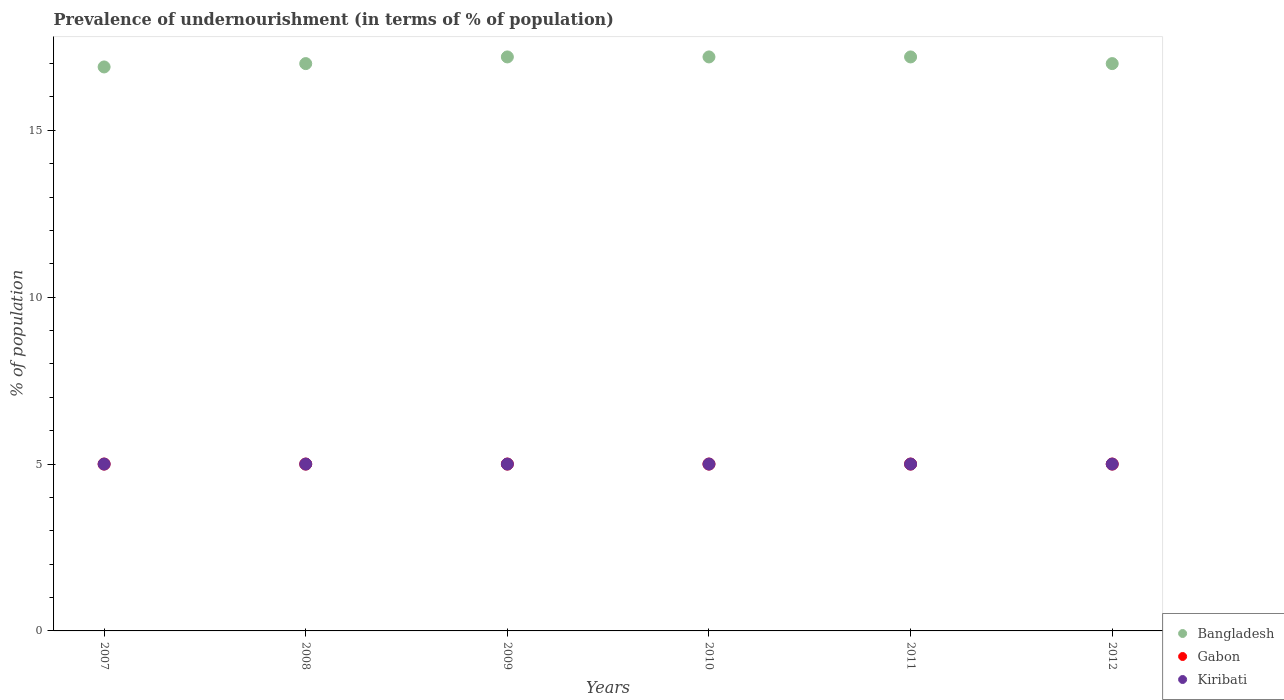How many different coloured dotlines are there?
Give a very brief answer. 3. What is the percentage of undernourished population in Gabon in 2009?
Provide a short and direct response. 5. Across all years, what is the maximum percentage of undernourished population in Gabon?
Offer a very short reply. 5. Across all years, what is the minimum percentage of undernourished population in Gabon?
Provide a short and direct response. 5. What is the difference between the percentage of undernourished population in Kiribati in 2012 and the percentage of undernourished population in Gabon in 2010?
Give a very brief answer. 0. What is the average percentage of undernourished population in Bangladesh per year?
Give a very brief answer. 17.08. What is the ratio of the percentage of undernourished population in Bangladesh in 2009 to that in 2012?
Offer a very short reply. 1.01. What is the difference between the highest and the second highest percentage of undernourished population in Kiribati?
Provide a short and direct response. 0. What is the difference between the highest and the lowest percentage of undernourished population in Bangladesh?
Your answer should be very brief. 0.3. Is the sum of the percentage of undernourished population in Gabon in 2008 and 2010 greater than the maximum percentage of undernourished population in Bangladesh across all years?
Your answer should be very brief. No. Is it the case that in every year, the sum of the percentage of undernourished population in Gabon and percentage of undernourished population in Kiribati  is greater than the percentage of undernourished population in Bangladesh?
Give a very brief answer. No. Is the percentage of undernourished population in Gabon strictly greater than the percentage of undernourished population in Bangladesh over the years?
Ensure brevity in your answer.  No. Is the percentage of undernourished population in Gabon strictly less than the percentage of undernourished population in Kiribati over the years?
Your response must be concise. No. How many dotlines are there?
Offer a terse response. 3. What is the difference between two consecutive major ticks on the Y-axis?
Make the answer very short. 5. Does the graph contain grids?
Offer a terse response. No. Where does the legend appear in the graph?
Provide a short and direct response. Bottom right. How are the legend labels stacked?
Ensure brevity in your answer.  Vertical. What is the title of the graph?
Provide a short and direct response. Prevalence of undernourishment (in terms of % of population). Does "Sweden" appear as one of the legend labels in the graph?
Make the answer very short. No. What is the label or title of the Y-axis?
Your response must be concise. % of population. What is the % of population in Bangladesh in 2008?
Ensure brevity in your answer.  17. What is the % of population in Gabon in 2008?
Provide a succinct answer. 5. What is the % of population in Gabon in 2009?
Give a very brief answer. 5. What is the % of population in Bangladesh in 2010?
Make the answer very short. 17.2. What is the % of population in Kiribati in 2010?
Offer a very short reply. 5. What is the % of population of Gabon in 2011?
Your answer should be compact. 5. What is the % of population of Bangladesh in 2012?
Keep it short and to the point. 17. Across all years, what is the maximum % of population in Bangladesh?
Keep it short and to the point. 17.2. Across all years, what is the minimum % of population of Bangladesh?
Give a very brief answer. 16.9. What is the total % of population in Bangladesh in the graph?
Offer a terse response. 102.5. What is the total % of population in Gabon in the graph?
Offer a very short reply. 30. What is the difference between the % of population of Bangladesh in 2007 and that in 2008?
Provide a succinct answer. -0.1. What is the difference between the % of population of Gabon in 2007 and that in 2008?
Your answer should be very brief. 0. What is the difference between the % of population of Kiribati in 2007 and that in 2008?
Offer a very short reply. 0. What is the difference between the % of population of Bangladesh in 2007 and that in 2009?
Make the answer very short. -0.3. What is the difference between the % of population in Gabon in 2007 and that in 2009?
Provide a succinct answer. 0. What is the difference between the % of population of Bangladesh in 2007 and that in 2011?
Your answer should be compact. -0.3. What is the difference between the % of population in Gabon in 2007 and that in 2011?
Ensure brevity in your answer.  0. What is the difference between the % of population in Kiribati in 2007 and that in 2011?
Provide a succinct answer. 0. What is the difference between the % of population in Gabon in 2007 and that in 2012?
Provide a short and direct response. 0. What is the difference between the % of population in Bangladesh in 2008 and that in 2009?
Provide a succinct answer. -0.2. What is the difference between the % of population of Bangladesh in 2008 and that in 2010?
Provide a succinct answer. -0.2. What is the difference between the % of population in Kiribati in 2008 and that in 2010?
Make the answer very short. 0. What is the difference between the % of population of Gabon in 2008 and that in 2011?
Your response must be concise. 0. What is the difference between the % of population in Kiribati in 2008 and that in 2011?
Your response must be concise. 0. What is the difference between the % of population of Bangladesh in 2008 and that in 2012?
Make the answer very short. 0. What is the difference between the % of population in Gabon in 2008 and that in 2012?
Provide a succinct answer. 0. What is the difference between the % of population in Bangladesh in 2009 and that in 2010?
Give a very brief answer. 0. What is the difference between the % of population of Kiribati in 2009 and that in 2010?
Your answer should be very brief. 0. What is the difference between the % of population in Bangladesh in 2009 and that in 2011?
Your answer should be compact. 0. What is the difference between the % of population in Gabon in 2009 and that in 2011?
Provide a succinct answer. 0. What is the difference between the % of population in Kiribati in 2009 and that in 2011?
Offer a terse response. 0. What is the difference between the % of population of Bangladesh in 2009 and that in 2012?
Give a very brief answer. 0.2. What is the difference between the % of population in Gabon in 2009 and that in 2012?
Offer a terse response. 0. What is the difference between the % of population of Kiribati in 2009 and that in 2012?
Offer a very short reply. 0. What is the difference between the % of population of Kiribati in 2010 and that in 2011?
Your answer should be compact. 0. What is the difference between the % of population in Bangladesh in 2010 and that in 2012?
Your response must be concise. 0.2. What is the difference between the % of population of Kiribati in 2011 and that in 2012?
Provide a short and direct response. 0. What is the difference between the % of population of Bangladesh in 2007 and the % of population of Kiribati in 2008?
Provide a succinct answer. 11.9. What is the difference between the % of population of Gabon in 2007 and the % of population of Kiribati in 2008?
Your answer should be very brief. 0. What is the difference between the % of population in Bangladesh in 2007 and the % of population in Gabon in 2009?
Your answer should be very brief. 11.9. What is the difference between the % of population in Bangladesh in 2007 and the % of population in Kiribati in 2009?
Keep it short and to the point. 11.9. What is the difference between the % of population in Bangladesh in 2007 and the % of population in Gabon in 2010?
Keep it short and to the point. 11.9. What is the difference between the % of population in Gabon in 2007 and the % of population in Kiribati in 2010?
Keep it short and to the point. 0. What is the difference between the % of population of Bangladesh in 2007 and the % of population of Gabon in 2011?
Keep it short and to the point. 11.9. What is the difference between the % of population of Gabon in 2007 and the % of population of Kiribati in 2011?
Provide a succinct answer. 0. What is the difference between the % of population in Bangladesh in 2007 and the % of population in Gabon in 2012?
Give a very brief answer. 11.9. What is the difference between the % of population in Bangladesh in 2007 and the % of population in Kiribati in 2012?
Offer a very short reply. 11.9. What is the difference between the % of population in Bangladesh in 2008 and the % of population in Gabon in 2009?
Offer a very short reply. 12. What is the difference between the % of population of Bangladesh in 2008 and the % of population of Kiribati in 2009?
Give a very brief answer. 12. What is the difference between the % of population of Gabon in 2008 and the % of population of Kiribati in 2009?
Provide a succinct answer. 0. What is the difference between the % of population in Bangladesh in 2008 and the % of population in Gabon in 2010?
Provide a short and direct response. 12. What is the difference between the % of population of Bangladesh in 2008 and the % of population of Kiribati in 2010?
Ensure brevity in your answer.  12. What is the difference between the % of population in Gabon in 2008 and the % of population in Kiribati in 2010?
Your answer should be compact. 0. What is the difference between the % of population of Bangladesh in 2008 and the % of population of Kiribati in 2011?
Your response must be concise. 12. What is the difference between the % of population of Gabon in 2008 and the % of population of Kiribati in 2012?
Ensure brevity in your answer.  0. What is the difference between the % of population of Bangladesh in 2009 and the % of population of Gabon in 2010?
Provide a succinct answer. 12.2. What is the difference between the % of population of Gabon in 2009 and the % of population of Kiribati in 2010?
Give a very brief answer. 0. What is the difference between the % of population in Bangladesh in 2009 and the % of population in Kiribati in 2011?
Provide a succinct answer. 12.2. What is the difference between the % of population in Gabon in 2009 and the % of population in Kiribati in 2011?
Keep it short and to the point. 0. What is the difference between the % of population of Bangladesh in 2009 and the % of population of Gabon in 2012?
Provide a short and direct response. 12.2. What is the difference between the % of population in Bangladesh in 2009 and the % of population in Kiribati in 2012?
Your answer should be very brief. 12.2. What is the difference between the % of population in Gabon in 2009 and the % of population in Kiribati in 2012?
Your answer should be very brief. 0. What is the difference between the % of population in Gabon in 2010 and the % of population in Kiribati in 2011?
Your answer should be very brief. 0. What is the difference between the % of population in Bangladesh in 2011 and the % of population in Gabon in 2012?
Provide a short and direct response. 12.2. What is the difference between the % of population in Bangladesh in 2011 and the % of population in Kiribati in 2012?
Provide a succinct answer. 12.2. What is the difference between the % of population of Gabon in 2011 and the % of population of Kiribati in 2012?
Keep it short and to the point. 0. What is the average % of population of Bangladesh per year?
Keep it short and to the point. 17.08. What is the average % of population in Kiribati per year?
Offer a very short reply. 5. In the year 2007, what is the difference between the % of population of Bangladesh and % of population of Kiribati?
Give a very brief answer. 11.9. In the year 2008, what is the difference between the % of population of Bangladesh and % of population of Gabon?
Your answer should be very brief. 12. In the year 2008, what is the difference between the % of population in Bangladesh and % of population in Kiribati?
Make the answer very short. 12. In the year 2008, what is the difference between the % of population in Gabon and % of population in Kiribati?
Your answer should be very brief. 0. In the year 2009, what is the difference between the % of population of Bangladesh and % of population of Gabon?
Keep it short and to the point. 12.2. In the year 2009, what is the difference between the % of population of Bangladesh and % of population of Kiribati?
Your answer should be very brief. 12.2. In the year 2009, what is the difference between the % of population of Gabon and % of population of Kiribati?
Your answer should be very brief. 0. In the year 2010, what is the difference between the % of population of Gabon and % of population of Kiribati?
Make the answer very short. 0. In the year 2011, what is the difference between the % of population in Bangladesh and % of population in Gabon?
Keep it short and to the point. 12.2. In the year 2012, what is the difference between the % of population in Bangladesh and % of population in Gabon?
Ensure brevity in your answer.  12. What is the ratio of the % of population in Gabon in 2007 to that in 2008?
Offer a very short reply. 1. What is the ratio of the % of population in Kiribati in 2007 to that in 2008?
Keep it short and to the point. 1. What is the ratio of the % of population of Bangladesh in 2007 to that in 2009?
Keep it short and to the point. 0.98. What is the ratio of the % of population in Kiribati in 2007 to that in 2009?
Give a very brief answer. 1. What is the ratio of the % of population of Bangladesh in 2007 to that in 2010?
Make the answer very short. 0.98. What is the ratio of the % of population in Kiribati in 2007 to that in 2010?
Your answer should be very brief. 1. What is the ratio of the % of population in Bangladesh in 2007 to that in 2011?
Your answer should be very brief. 0.98. What is the ratio of the % of population in Gabon in 2007 to that in 2012?
Ensure brevity in your answer.  1. What is the ratio of the % of population of Bangladesh in 2008 to that in 2009?
Keep it short and to the point. 0.99. What is the ratio of the % of population in Bangladesh in 2008 to that in 2010?
Ensure brevity in your answer.  0.99. What is the ratio of the % of population of Bangladesh in 2008 to that in 2011?
Offer a terse response. 0.99. What is the ratio of the % of population in Gabon in 2008 to that in 2011?
Your answer should be very brief. 1. What is the ratio of the % of population of Kiribati in 2008 to that in 2011?
Provide a short and direct response. 1. What is the ratio of the % of population of Bangladesh in 2008 to that in 2012?
Provide a short and direct response. 1. What is the ratio of the % of population in Gabon in 2008 to that in 2012?
Ensure brevity in your answer.  1. What is the ratio of the % of population of Bangladesh in 2009 to that in 2010?
Your answer should be very brief. 1. What is the ratio of the % of population of Bangladesh in 2009 to that in 2011?
Provide a short and direct response. 1. What is the ratio of the % of population in Bangladesh in 2009 to that in 2012?
Make the answer very short. 1.01. What is the ratio of the % of population in Gabon in 2009 to that in 2012?
Provide a short and direct response. 1. What is the ratio of the % of population of Bangladesh in 2010 to that in 2011?
Give a very brief answer. 1. What is the ratio of the % of population in Gabon in 2010 to that in 2011?
Make the answer very short. 1. What is the ratio of the % of population in Bangladesh in 2010 to that in 2012?
Provide a succinct answer. 1.01. What is the ratio of the % of population of Gabon in 2010 to that in 2012?
Your response must be concise. 1. What is the ratio of the % of population of Bangladesh in 2011 to that in 2012?
Offer a terse response. 1.01. What is the ratio of the % of population in Gabon in 2011 to that in 2012?
Your answer should be compact. 1. What is the difference between the highest and the second highest % of population in Bangladesh?
Offer a very short reply. 0. What is the difference between the highest and the second highest % of population of Gabon?
Make the answer very short. 0. What is the difference between the highest and the second highest % of population in Kiribati?
Keep it short and to the point. 0. What is the difference between the highest and the lowest % of population in Bangladesh?
Provide a short and direct response. 0.3. What is the difference between the highest and the lowest % of population of Gabon?
Ensure brevity in your answer.  0. 